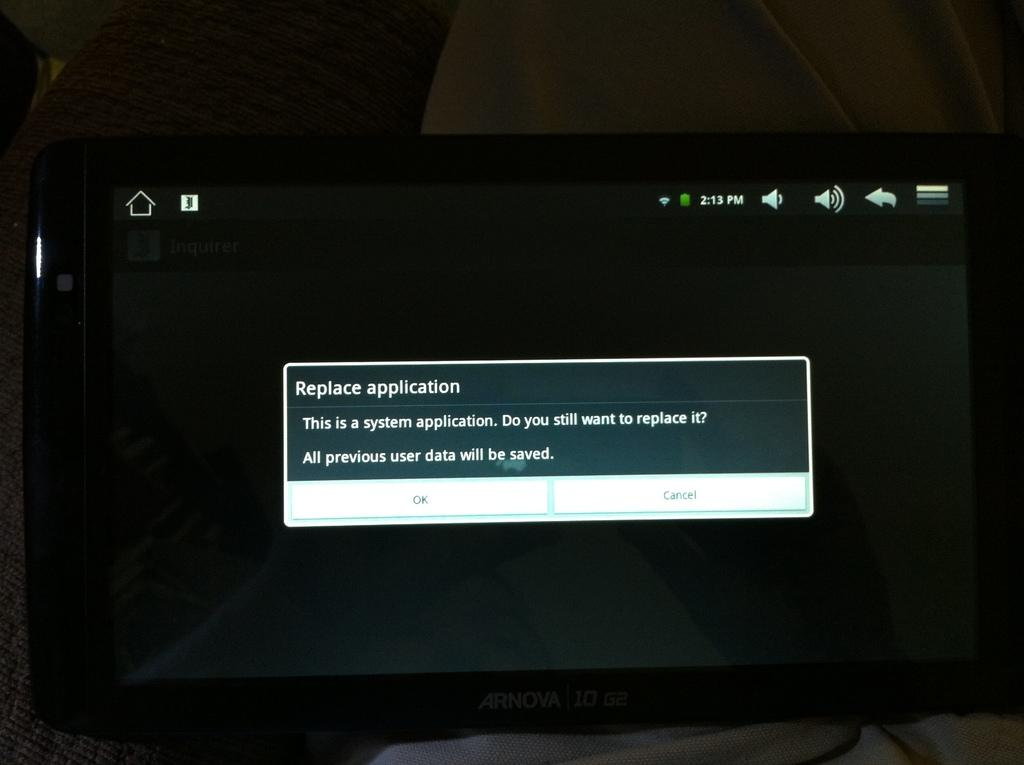<image>
Write a terse but informative summary of the picture. Replace Application is the header of this prompt shown on the computer screen. 